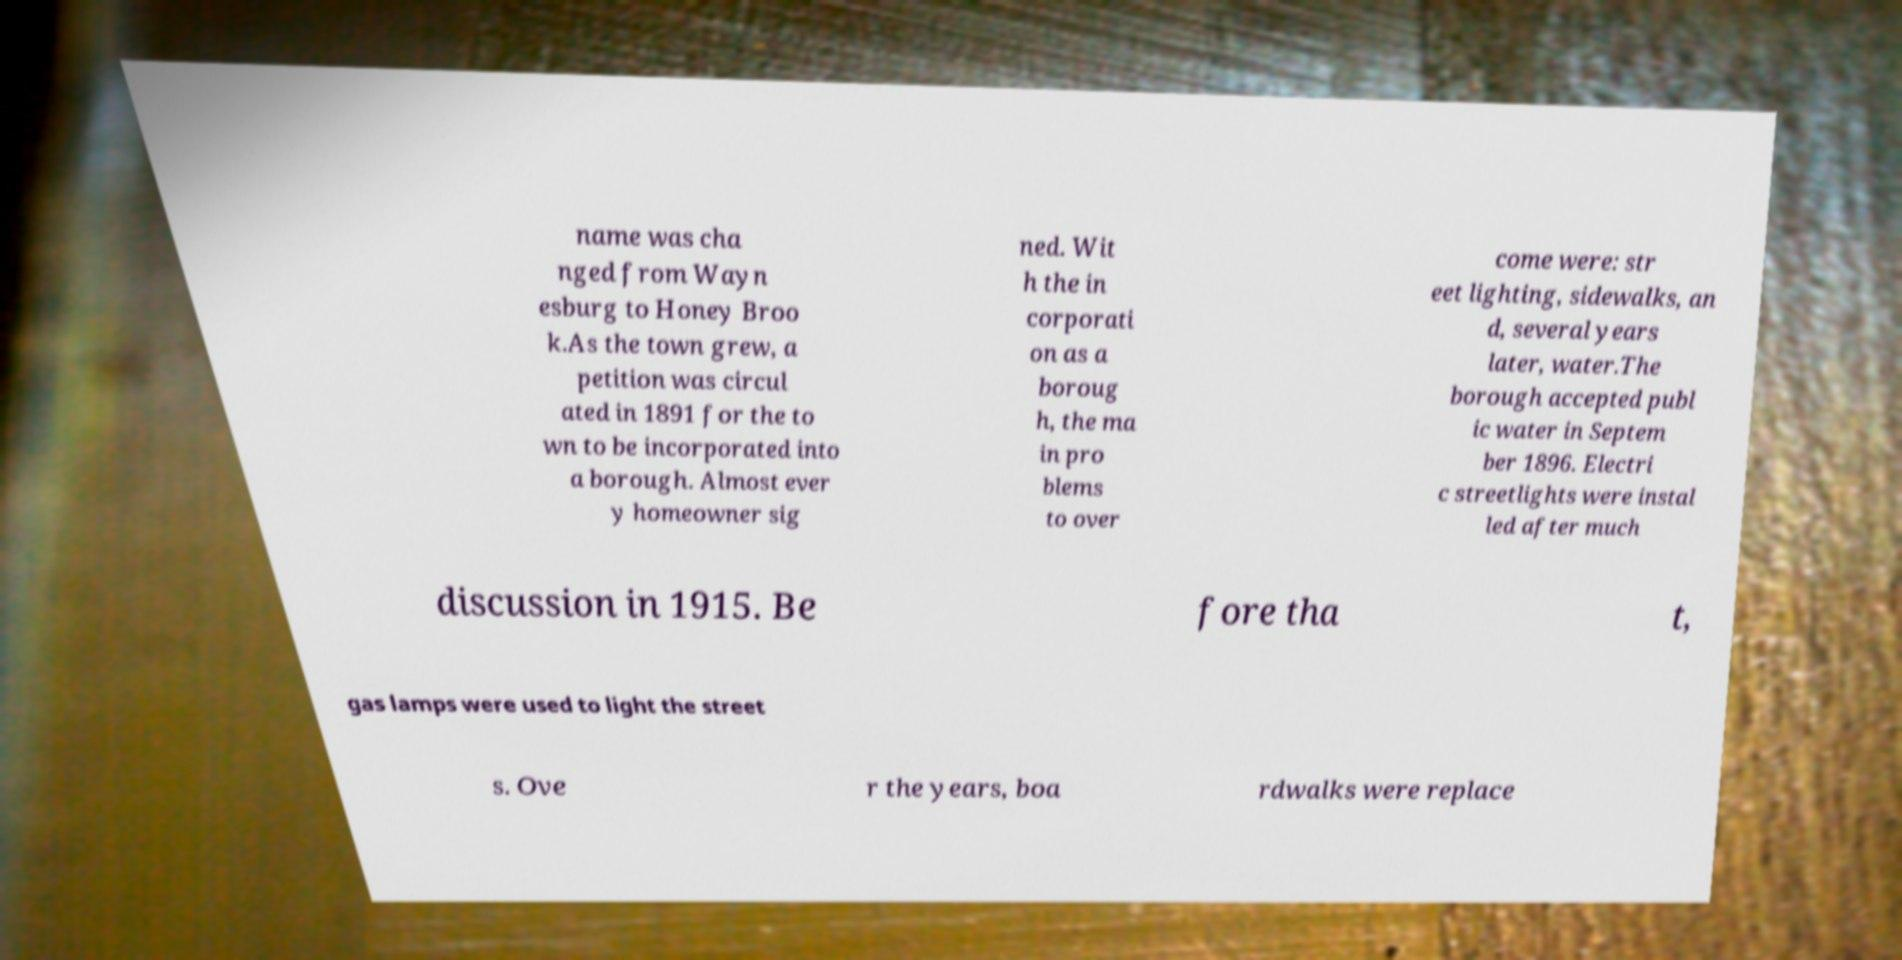Please read and relay the text visible in this image. What does it say? name was cha nged from Wayn esburg to Honey Broo k.As the town grew, a petition was circul ated in 1891 for the to wn to be incorporated into a borough. Almost ever y homeowner sig ned. Wit h the in corporati on as a boroug h, the ma in pro blems to over come were: str eet lighting, sidewalks, an d, several years later, water.The borough accepted publ ic water in Septem ber 1896. Electri c streetlights were instal led after much discussion in 1915. Be fore tha t, gas lamps were used to light the street s. Ove r the years, boa rdwalks were replace 